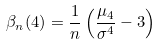Convert formula to latex. <formula><loc_0><loc_0><loc_500><loc_500>\beta _ { n } ( 4 ) = \frac { 1 } { n } \left ( \frac { \mu _ { 4 } } { \sigma ^ { 4 } } - 3 \right )</formula> 